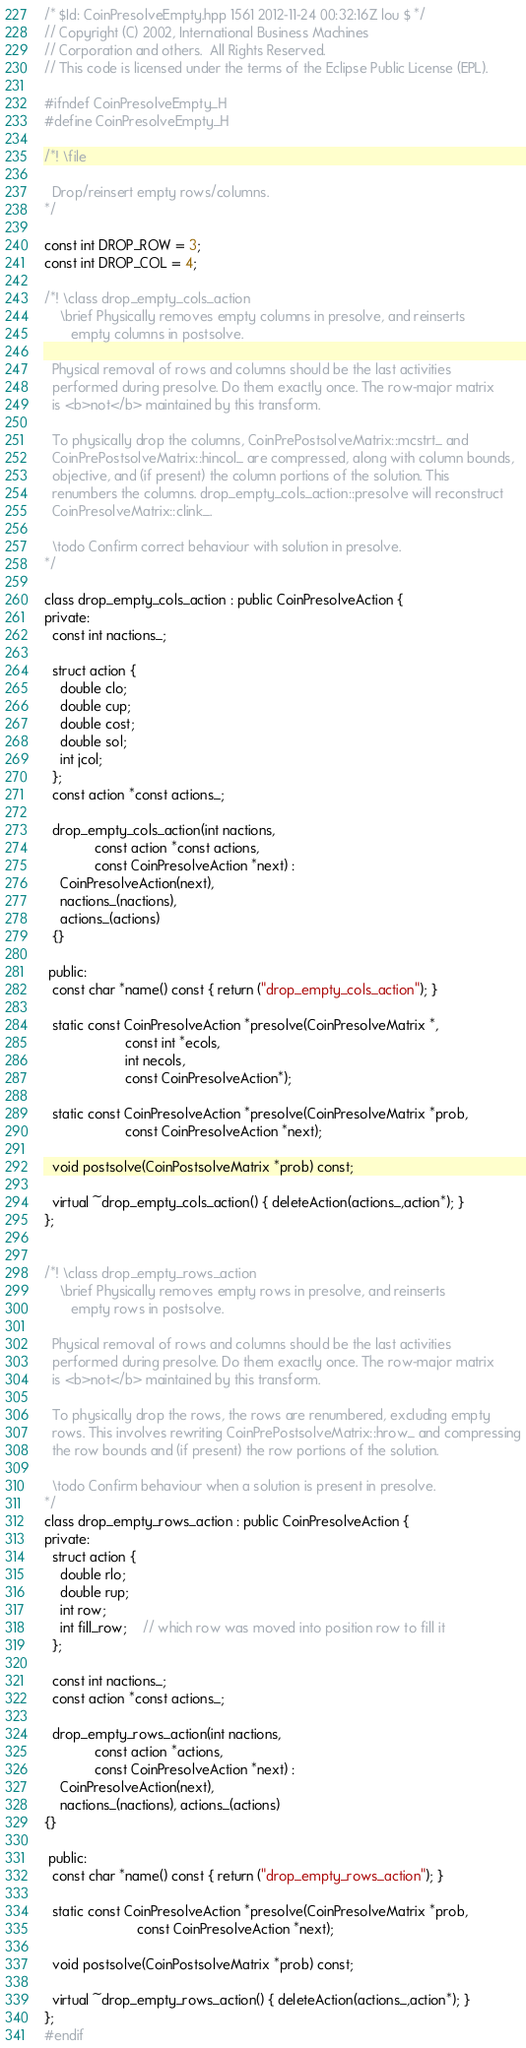<code> <loc_0><loc_0><loc_500><loc_500><_C++_>/* $Id: CoinPresolveEmpty.hpp 1561 2012-11-24 00:32:16Z lou $ */
// Copyright (C) 2002, International Business Machines
// Corporation and others.  All Rights Reserved.
// This code is licensed under the terms of the Eclipse Public License (EPL).

#ifndef CoinPresolveEmpty_H
#define CoinPresolveEmpty_H

/*! \file

  Drop/reinsert empty rows/columns.
*/

const int DROP_ROW = 3;
const int DROP_COL = 4;

/*! \class drop_empty_cols_action
    \brief Physically removes empty columns in presolve, and reinserts
	   empty columns in postsolve.

  Physical removal of rows and columns should be the last activities
  performed during presolve. Do them exactly once. The row-major matrix
  is <b>not</b> maintained by this transform.

  To physically drop the columns, CoinPrePostsolveMatrix::mcstrt_ and
  CoinPrePostsolveMatrix::hincol_ are compressed, along with column bounds,
  objective, and (if present) the column portions of the solution. This
  renumbers the columns. drop_empty_cols_action::presolve will reconstruct
  CoinPresolveMatrix::clink_.

  \todo Confirm correct behaviour with solution in presolve.
*/

class drop_empty_cols_action : public CoinPresolveAction {
private:
  const int nactions_;

  struct action {
    double clo;
    double cup;
    double cost;
    double sol;
    int jcol;
  };
  const action *const actions_;

  drop_empty_cols_action(int nactions,
			 const action *const actions,
			 const CoinPresolveAction *next) :
    CoinPresolveAction(next),
    nactions_(nactions), 
    actions_(actions)
  {}

 public:
  const char *name() const { return ("drop_empty_cols_action"); }

  static const CoinPresolveAction *presolve(CoinPresolveMatrix *,
					 const int *ecols,
					 int necols,
					 const CoinPresolveAction*);

  static const CoinPresolveAction *presolve(CoinPresolveMatrix *prob,
					 const CoinPresolveAction *next);

  void postsolve(CoinPostsolveMatrix *prob) const;

  virtual ~drop_empty_cols_action() { deleteAction(actions_,action*); }
};


/*! \class drop_empty_rows_action
    \brief Physically removes empty rows in presolve, and reinserts
	   empty rows in postsolve.

  Physical removal of rows and columns should be the last activities
  performed during presolve. Do them exactly once. The row-major matrix
  is <b>not</b> maintained by this transform.

  To physically drop the rows, the rows are renumbered, excluding empty
  rows. This involves rewriting CoinPrePostsolveMatrix::hrow_ and compressing
  the row bounds and (if present) the row portions of the solution.

  \todo Confirm behaviour when a solution is present in presolve.
*/
class drop_empty_rows_action : public CoinPresolveAction {
private:
  struct action {
    double rlo;
    double rup;
    int row;
    int fill_row;	// which row was moved into position row to fill it
  };

  const int nactions_;
  const action *const actions_;

  drop_empty_rows_action(int nactions,
			 const action *actions,
			 const CoinPresolveAction *next) :
    CoinPresolveAction(next),
    nactions_(nactions), actions_(actions)
{}

 public:
  const char *name() const { return ("drop_empty_rows_action"); }

  static const CoinPresolveAction *presolve(CoinPresolveMatrix *prob,
					    const CoinPresolveAction *next);

  void postsolve(CoinPostsolveMatrix *prob) const;

  virtual ~drop_empty_rows_action() { deleteAction(actions_,action*); }
};
#endif

</code> 